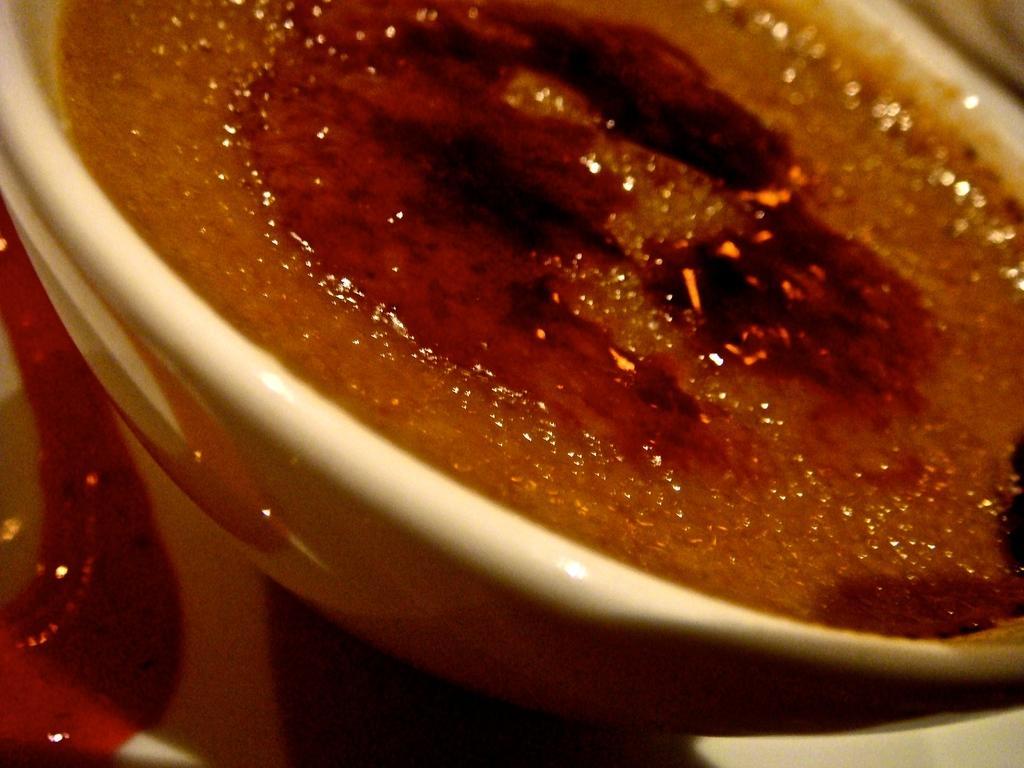Could you give a brief overview of what you see in this image? In this image I can see a bowl which consists of some food item. On the left side there is an object. 